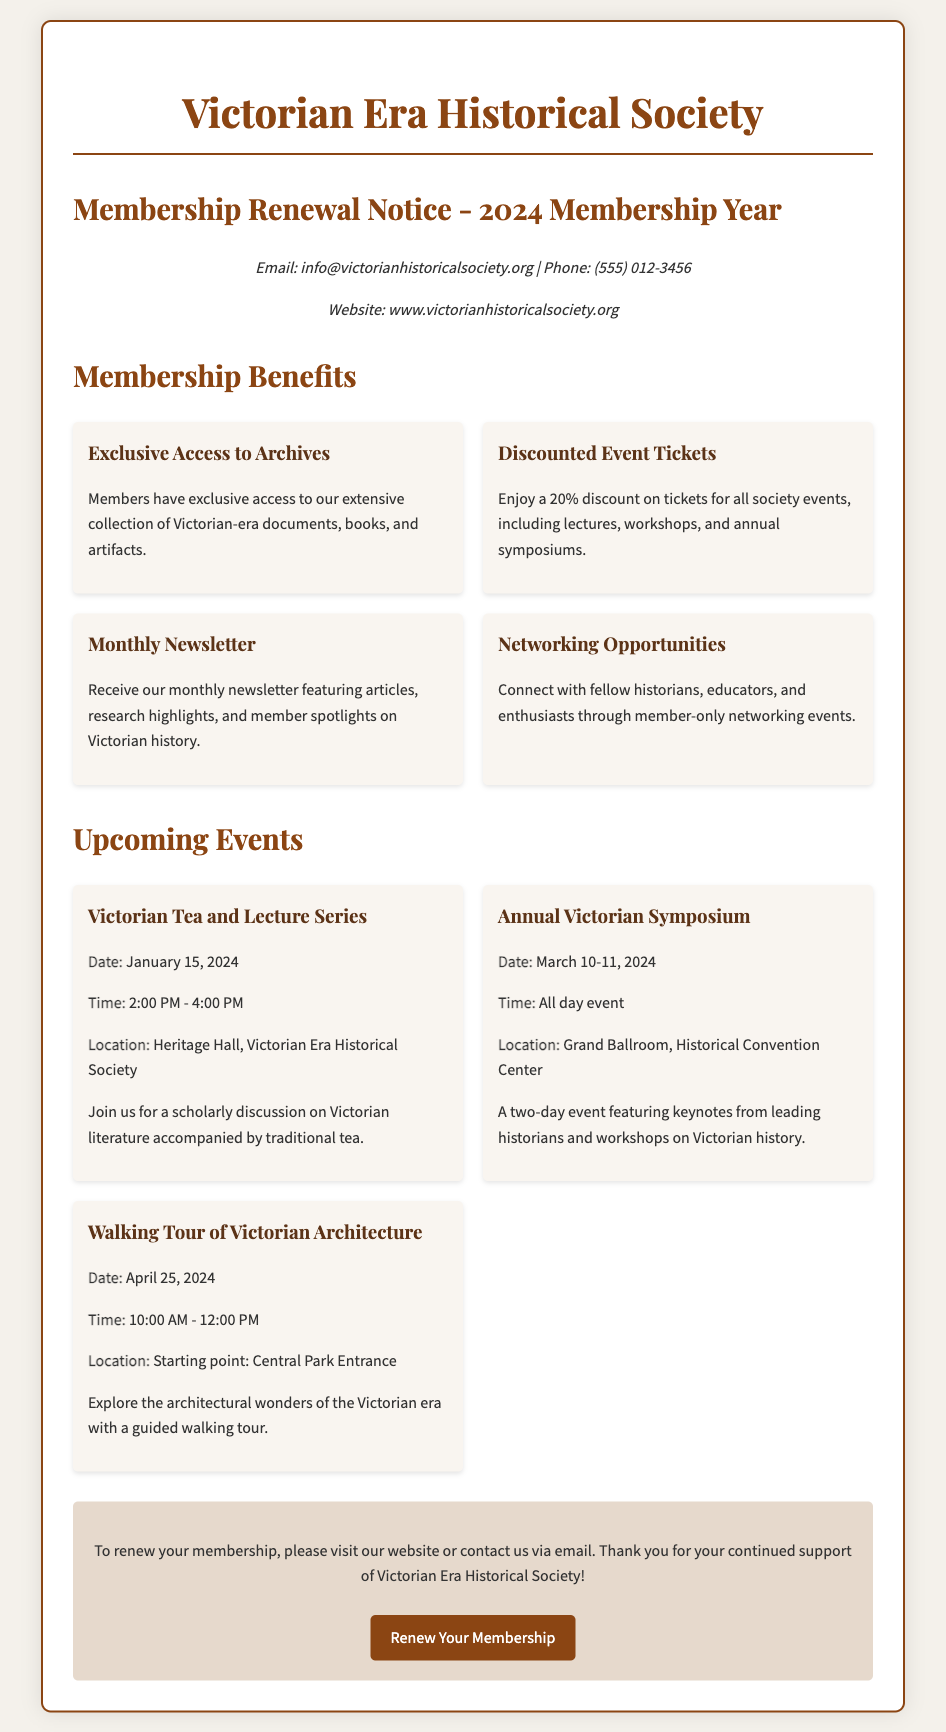What is the name of the society? The name of the society is explicitly stated as "Victorian Era Historical Society."
Answer: Victorian Era Historical Society What is the website for membership renewal? The website provided in the document is where members can renew their membership, which is "www.victorianhistoricalsociety.org."
Answer: www.victorianhistoricalsociety.org How much is the discount on event tickets for members? The document mentions a "20% discount" on tickets for all society events specifically for members.
Answer: 20% When is the Annual Victorian Symposium scheduled? The date for the "Annual Victorian Symposium" is provided as "March 10-11, 2024."
Answer: March 10-11, 2024 What type of event is scheduled for January 15, 2024? A "Victorian Tea and Lecture Series" is the event noted for that date.
Answer: Victorian Tea and Lecture Series What is one benefit of membership listed in the document? The document lists several benefits, including "Exclusive Access to Archives," which members enjoy.
Answer: Exclusive Access to Archives Where will the Walking Tour of Victorian Architecture begin? The starting point for the Walking Tour is stated as "Central Park Entrance" in the document.
Answer: Central Park Entrance How long is the Walking Tour of Victorian Architecture? The document specifies the duration of the Walking Tour as "2 hours," from 10:00 AM to 12:00 PM.
Answer: 2 hours What is the contact phone number for the society? The phone number provided in the document for contact is "(555) 012-3456."
Answer: (555) 012-3456 